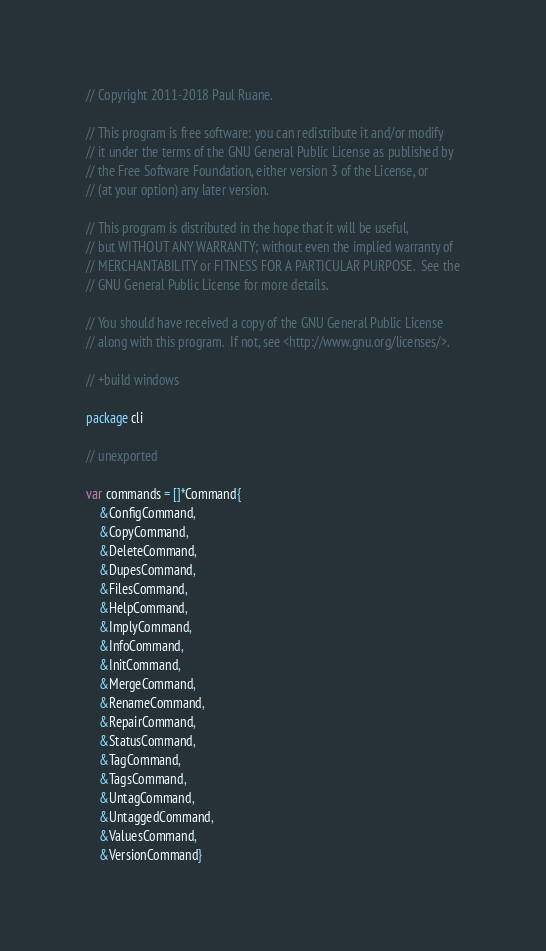Convert code to text. <code><loc_0><loc_0><loc_500><loc_500><_Go_>// Copyright 2011-2018 Paul Ruane.

// This program is free software: you can redistribute it and/or modify
// it under the terms of the GNU General Public License as published by
// the Free Software Foundation, either version 3 of the License, or
// (at your option) any later version.

// This program is distributed in the hope that it will be useful,
// but WITHOUT ANY WARRANTY; without even the implied warranty of
// MERCHANTABILITY or FITNESS FOR A PARTICULAR PURPOSE.  See the
// GNU General Public License for more details.

// You should have received a copy of the GNU General Public License
// along with this program.  If not, see <http://www.gnu.org/licenses/>.

// +build windows

package cli

// unexported

var commands = []*Command{
	&ConfigCommand,
	&CopyCommand,
	&DeleteCommand,
	&DupesCommand,
	&FilesCommand,
	&HelpCommand,
	&ImplyCommand,
	&InfoCommand,
	&InitCommand,
	&MergeCommand,
	&RenameCommand,
	&RepairCommand,
	&StatusCommand,
	&TagCommand,
	&TagsCommand,
	&UntagCommand,
	&UntaggedCommand,
	&ValuesCommand,
	&VersionCommand}
</code> 